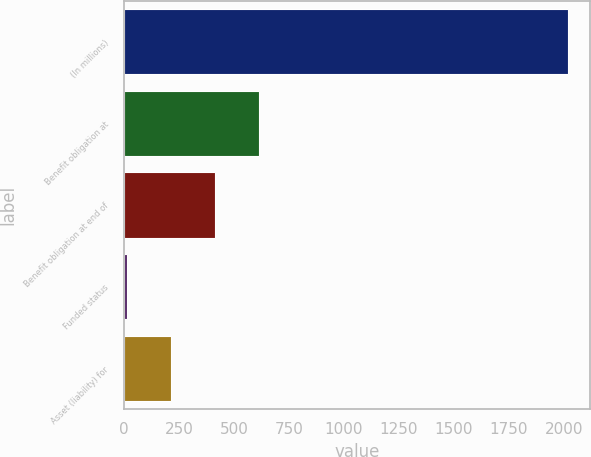Convert chart. <chart><loc_0><loc_0><loc_500><loc_500><bar_chart><fcel>(In millions)<fcel>Benefit obligation at<fcel>Benefit obligation at end of<fcel>Funded status<fcel>Asset (liability) for<nl><fcel>2017<fcel>614.9<fcel>414.6<fcel>14<fcel>214.3<nl></chart> 